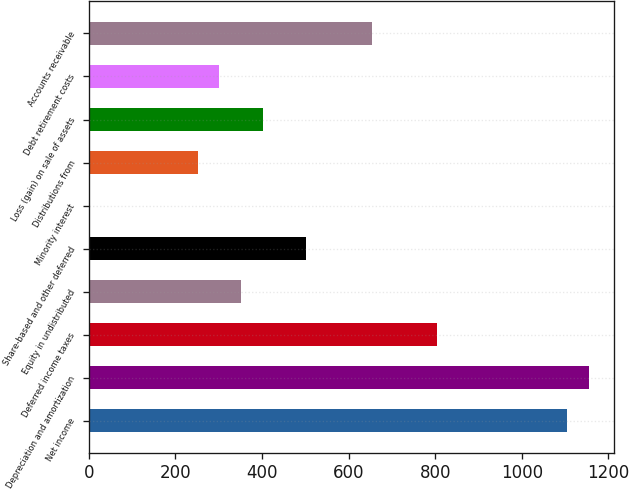Convert chart. <chart><loc_0><loc_0><loc_500><loc_500><bar_chart><fcel>Net income<fcel>Depreciation and amortization<fcel>Deferred income taxes<fcel>Equity in undistributed<fcel>Share-based and other deferred<fcel>Minority interest<fcel>Distributions from<fcel>Loss (gain) on sale of assets<fcel>Debt retirement costs<fcel>Accounts receivable<nl><fcel>1105.36<fcel>1155.59<fcel>803.98<fcel>351.91<fcel>502.6<fcel>0.3<fcel>251.45<fcel>402.14<fcel>301.68<fcel>653.29<nl></chart> 